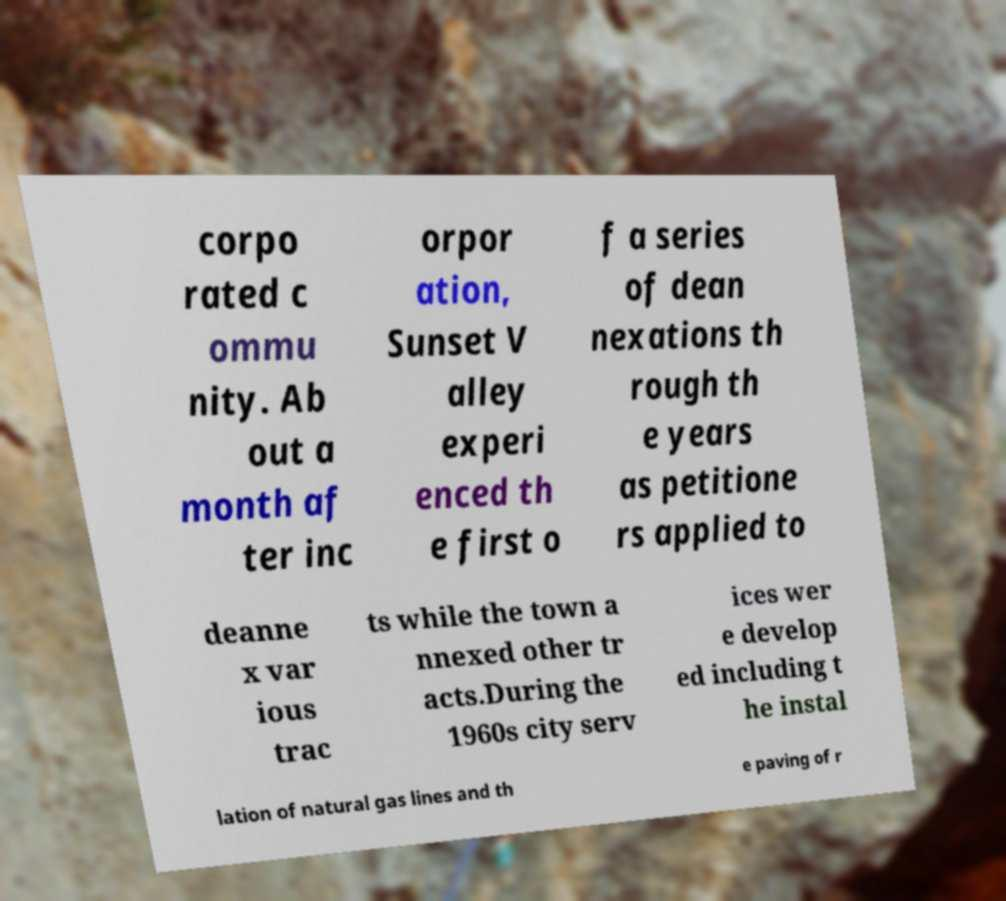For documentation purposes, I need the text within this image transcribed. Could you provide that? corpo rated c ommu nity. Ab out a month af ter inc orpor ation, Sunset V alley experi enced th e first o f a series of dean nexations th rough th e years as petitione rs applied to deanne x var ious trac ts while the town a nnexed other tr acts.During the 1960s city serv ices wer e develop ed including t he instal lation of natural gas lines and th e paving of r 